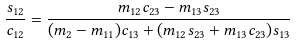<formula> <loc_0><loc_0><loc_500><loc_500>\frac { s _ { 1 2 } } { c _ { 1 2 } } = \frac { m _ { 1 2 } c _ { 2 3 } - m _ { 1 3 } s _ { 2 3 } } { ( m _ { 2 } - m _ { 1 1 } ) c _ { 1 3 } + ( m _ { 1 2 } s _ { 2 3 } + m _ { 1 3 } c _ { 2 3 } ) s _ { 1 3 } }</formula> 